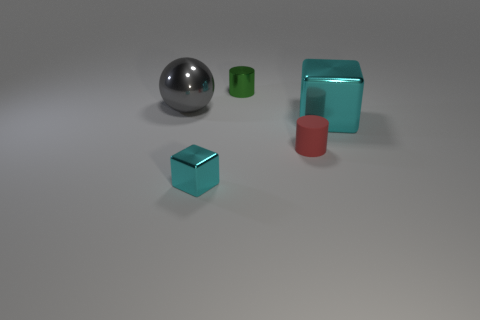Is there a metallic ball on the right side of the metallic cube that is right of the tiny green cylinder?
Keep it short and to the point. No. What number of other objects are there of the same shape as the big cyan object?
Give a very brief answer. 1. Is the shape of the tiny green metallic object the same as the large cyan metallic thing?
Offer a terse response. No. There is a shiny object that is both to the right of the gray metal thing and behind the large cyan metal thing; what color is it?
Your answer should be compact. Green. There is another shiny cube that is the same color as the big metallic block; what size is it?
Make the answer very short. Small. How many big objects are green rubber cylinders or rubber cylinders?
Ensure brevity in your answer.  0. Is there any other thing that has the same color as the tiny block?
Ensure brevity in your answer.  Yes. What material is the small thing behind the cyan metal thing that is to the right of the tiny cylinder left of the matte thing?
Offer a terse response. Metal. How many rubber objects are either big green spheres or tiny green objects?
Your response must be concise. 0. What number of cyan objects are either shiny objects or small shiny cubes?
Make the answer very short. 2. 